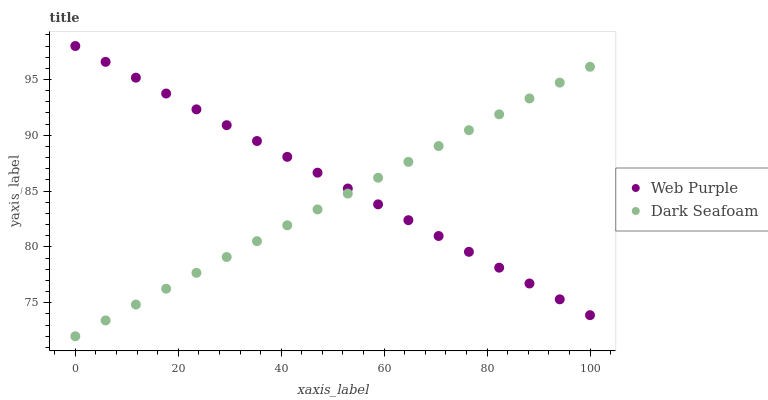Does Dark Seafoam have the minimum area under the curve?
Answer yes or no. Yes. Does Web Purple have the maximum area under the curve?
Answer yes or no. Yes. Does Dark Seafoam have the maximum area under the curve?
Answer yes or no. No. Is Web Purple the smoothest?
Answer yes or no. Yes. Is Dark Seafoam the roughest?
Answer yes or no. Yes. Is Dark Seafoam the smoothest?
Answer yes or no. No. Does Dark Seafoam have the lowest value?
Answer yes or no. Yes. Does Web Purple have the highest value?
Answer yes or no. Yes. Does Dark Seafoam have the highest value?
Answer yes or no. No. Does Dark Seafoam intersect Web Purple?
Answer yes or no. Yes. Is Dark Seafoam less than Web Purple?
Answer yes or no. No. Is Dark Seafoam greater than Web Purple?
Answer yes or no. No. 